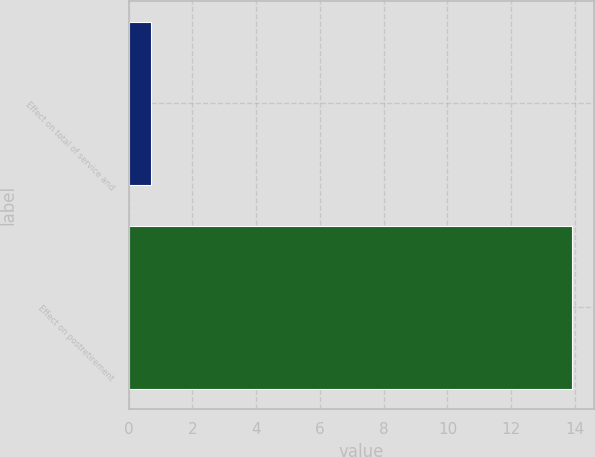Convert chart. <chart><loc_0><loc_0><loc_500><loc_500><bar_chart><fcel>Effect on total of service and<fcel>Effect on postretirement<nl><fcel>0.7<fcel>13.9<nl></chart> 